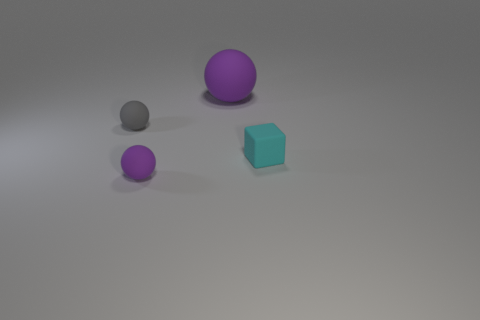Add 1 small cyan matte blocks. How many objects exist? 5 Subtract all balls. How many objects are left? 1 Add 4 small gray metal spheres. How many small gray metal spheres exist? 4 Subtract 1 cyan blocks. How many objects are left? 3 Subtract all cyan spheres. Subtract all small gray objects. How many objects are left? 3 Add 3 purple balls. How many purple balls are left? 5 